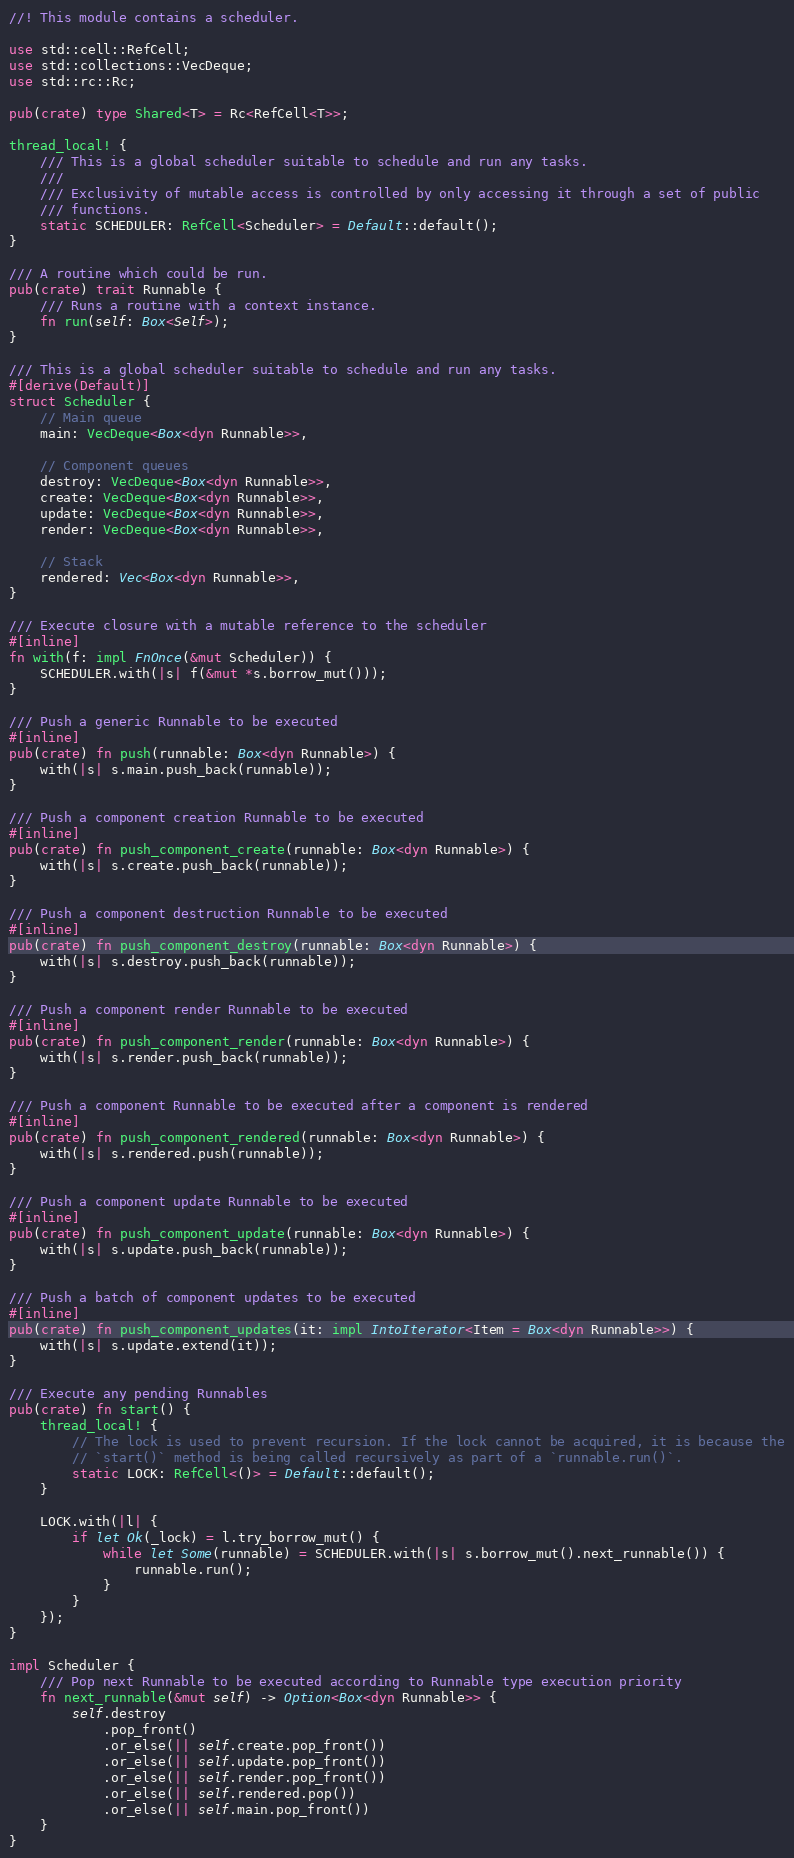Convert code to text. <code><loc_0><loc_0><loc_500><loc_500><_Rust_>//! This module contains a scheduler.

use std::cell::RefCell;
use std::collections::VecDeque;
use std::rc::Rc;

pub(crate) type Shared<T> = Rc<RefCell<T>>;

thread_local! {
    /// This is a global scheduler suitable to schedule and run any tasks.
    ///
    /// Exclusivity of mutable access is controlled by only accessing it through a set of public
    /// functions.
    static SCHEDULER: RefCell<Scheduler> = Default::default();
}

/// A routine which could be run.
pub(crate) trait Runnable {
    /// Runs a routine with a context instance.
    fn run(self: Box<Self>);
}

/// This is a global scheduler suitable to schedule and run any tasks.
#[derive(Default)]
struct Scheduler {
    // Main queue
    main: VecDeque<Box<dyn Runnable>>,

    // Component queues
    destroy: VecDeque<Box<dyn Runnable>>,
    create: VecDeque<Box<dyn Runnable>>,
    update: VecDeque<Box<dyn Runnable>>,
    render: VecDeque<Box<dyn Runnable>>,

    // Stack
    rendered: Vec<Box<dyn Runnable>>,
}

/// Execute closure with a mutable reference to the scheduler
#[inline]
fn with(f: impl FnOnce(&mut Scheduler)) {
    SCHEDULER.with(|s| f(&mut *s.borrow_mut()));
}

/// Push a generic Runnable to be executed
#[inline]
pub(crate) fn push(runnable: Box<dyn Runnable>) {
    with(|s| s.main.push_back(runnable));
}

/// Push a component creation Runnable to be executed
#[inline]
pub(crate) fn push_component_create(runnable: Box<dyn Runnable>) {
    with(|s| s.create.push_back(runnable));
}

/// Push a component destruction Runnable to be executed
#[inline]
pub(crate) fn push_component_destroy(runnable: Box<dyn Runnable>) {
    with(|s| s.destroy.push_back(runnable));
}

/// Push a component render Runnable to be executed
#[inline]
pub(crate) fn push_component_render(runnable: Box<dyn Runnable>) {
    with(|s| s.render.push_back(runnable));
}

/// Push a component Runnable to be executed after a component is rendered
#[inline]
pub(crate) fn push_component_rendered(runnable: Box<dyn Runnable>) {
    with(|s| s.rendered.push(runnable));
}

/// Push a component update Runnable to be executed
#[inline]
pub(crate) fn push_component_update(runnable: Box<dyn Runnable>) {
    with(|s| s.update.push_back(runnable));
}

/// Push a batch of component updates to be executed
#[inline]
pub(crate) fn push_component_updates(it: impl IntoIterator<Item = Box<dyn Runnable>>) {
    with(|s| s.update.extend(it));
}

/// Execute any pending Runnables
pub(crate) fn start() {
    thread_local! {
        // The lock is used to prevent recursion. If the lock cannot be acquired, it is because the
        // `start()` method is being called recursively as part of a `runnable.run()`.
        static LOCK: RefCell<()> = Default::default();
    }

    LOCK.with(|l| {
        if let Ok(_lock) = l.try_borrow_mut() {
            while let Some(runnable) = SCHEDULER.with(|s| s.borrow_mut().next_runnable()) {
                runnable.run();
            }
        }
    });
}

impl Scheduler {
    /// Pop next Runnable to be executed according to Runnable type execution priority
    fn next_runnable(&mut self) -> Option<Box<dyn Runnable>> {
        self.destroy
            .pop_front()
            .or_else(|| self.create.pop_front())
            .or_else(|| self.update.pop_front())
            .or_else(|| self.render.pop_front())
            .or_else(|| self.rendered.pop())
            .or_else(|| self.main.pop_front())
    }
}
</code> 